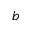Convert formula to latex. <formula><loc_0><loc_0><loc_500><loc_500>b</formula> 